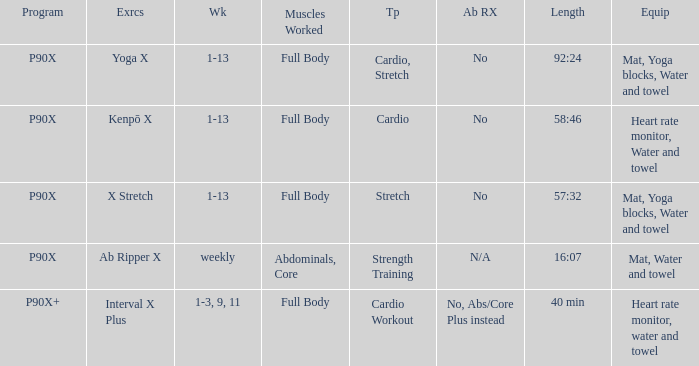How many types are cardio? 1.0. 